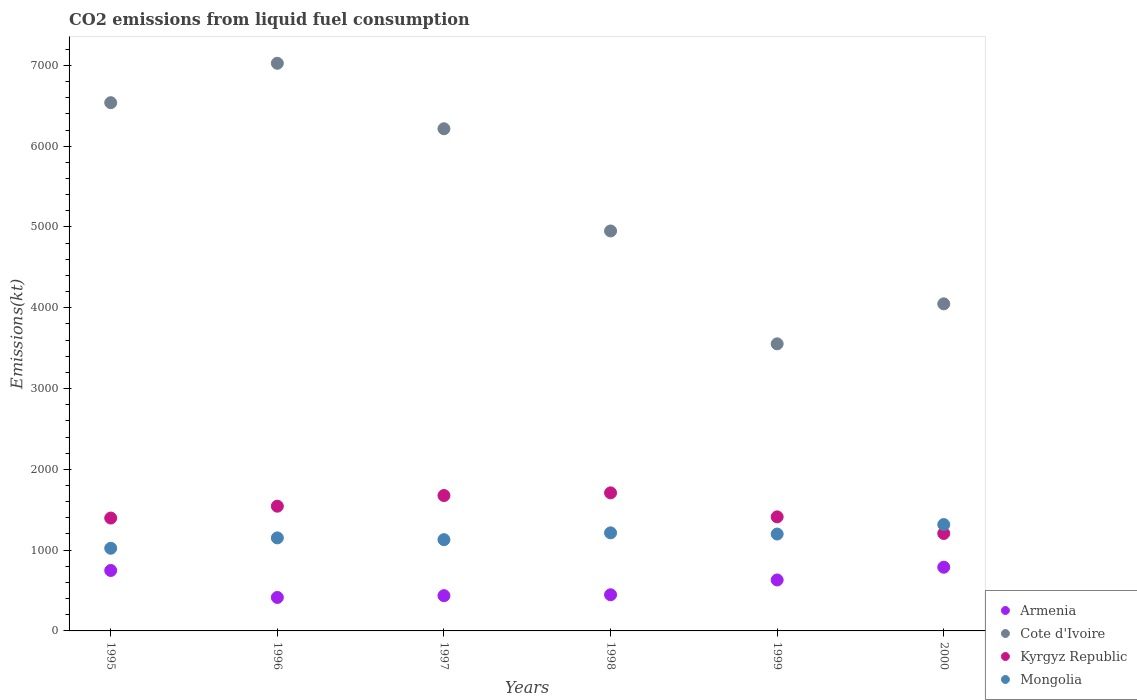What is the amount of CO2 emitted in Armenia in 2000?
Make the answer very short. 788.4. Across all years, what is the maximum amount of CO2 emitted in Armenia?
Keep it short and to the point. 788.4. Across all years, what is the minimum amount of CO2 emitted in Cote d'Ivoire?
Your answer should be compact. 3553.32. What is the total amount of CO2 emitted in Kyrgyz Republic in the graph?
Give a very brief answer. 8943.81. What is the difference between the amount of CO2 emitted in Kyrgyz Republic in 1997 and that in 1998?
Your response must be concise. -33. What is the difference between the amount of CO2 emitted in Mongolia in 1995 and the amount of CO2 emitted in Cote d'Ivoire in 1997?
Provide a succinct answer. -5192.47. What is the average amount of CO2 emitted in Kyrgyz Republic per year?
Provide a succinct answer. 1490.64. In the year 1996, what is the difference between the amount of CO2 emitted in Kyrgyz Republic and amount of CO2 emitted in Mongolia?
Provide a succinct answer. 392.37. What is the ratio of the amount of CO2 emitted in Cote d'Ivoire in 1996 to that in 1998?
Make the answer very short. 1.42. Is the amount of CO2 emitted in Cote d'Ivoire in 1996 less than that in 1997?
Give a very brief answer. No. What is the difference between the highest and the second highest amount of CO2 emitted in Cote d'Ivoire?
Your answer should be very brief. 487.71. What is the difference between the highest and the lowest amount of CO2 emitted in Kyrgyz Republic?
Offer a terse response. 502.38. Is the sum of the amount of CO2 emitted in Armenia in 1995 and 1999 greater than the maximum amount of CO2 emitted in Cote d'Ivoire across all years?
Make the answer very short. No. Is the amount of CO2 emitted in Kyrgyz Republic strictly greater than the amount of CO2 emitted in Mongolia over the years?
Give a very brief answer. No. Is the amount of CO2 emitted in Mongolia strictly less than the amount of CO2 emitted in Kyrgyz Republic over the years?
Keep it short and to the point. No. How many dotlines are there?
Keep it short and to the point. 4. What is the difference between two consecutive major ticks on the Y-axis?
Your answer should be compact. 1000. Are the values on the major ticks of Y-axis written in scientific E-notation?
Give a very brief answer. No. Does the graph contain any zero values?
Offer a very short reply. No. How are the legend labels stacked?
Give a very brief answer. Vertical. What is the title of the graph?
Offer a terse response. CO2 emissions from liquid fuel consumption. What is the label or title of the Y-axis?
Make the answer very short. Emissions(kt). What is the Emissions(kt) in Armenia in 1995?
Give a very brief answer. 748.07. What is the Emissions(kt) of Cote d'Ivoire in 1995?
Your answer should be compact. 6538.26. What is the Emissions(kt) in Kyrgyz Republic in 1995?
Keep it short and to the point. 1397.13. What is the Emissions(kt) of Mongolia in 1995?
Provide a short and direct response. 1023.09. What is the Emissions(kt) in Armenia in 1996?
Offer a terse response. 414.37. What is the Emissions(kt) of Cote d'Ivoire in 1996?
Offer a terse response. 7025.97. What is the Emissions(kt) of Kyrgyz Republic in 1996?
Your answer should be compact. 1543.81. What is the Emissions(kt) of Mongolia in 1996?
Provide a short and direct response. 1151.44. What is the Emissions(kt) of Armenia in 1997?
Your answer should be very brief. 436.37. What is the Emissions(kt) in Cote d'Ivoire in 1997?
Provide a short and direct response. 6215.56. What is the Emissions(kt) of Kyrgyz Republic in 1997?
Offer a very short reply. 1675.82. What is the Emissions(kt) in Mongolia in 1997?
Offer a terse response. 1129.44. What is the Emissions(kt) in Armenia in 1998?
Provide a short and direct response. 447.37. What is the Emissions(kt) in Cote d'Ivoire in 1998?
Give a very brief answer. 4950.45. What is the Emissions(kt) in Kyrgyz Republic in 1998?
Your response must be concise. 1708.82. What is the Emissions(kt) of Mongolia in 1998?
Make the answer very short. 1213.78. What is the Emissions(kt) in Armenia in 1999?
Your answer should be compact. 630.72. What is the Emissions(kt) in Cote d'Ivoire in 1999?
Keep it short and to the point. 3553.32. What is the Emissions(kt) in Kyrgyz Republic in 1999?
Make the answer very short. 1411.8. What is the Emissions(kt) of Mongolia in 1999?
Ensure brevity in your answer.  1199.11. What is the Emissions(kt) in Armenia in 2000?
Offer a very short reply. 788.4. What is the Emissions(kt) of Cote d'Ivoire in 2000?
Offer a very short reply. 4048.37. What is the Emissions(kt) in Kyrgyz Republic in 2000?
Make the answer very short. 1206.44. What is the Emissions(kt) of Mongolia in 2000?
Ensure brevity in your answer.  1316.45. Across all years, what is the maximum Emissions(kt) in Armenia?
Your answer should be very brief. 788.4. Across all years, what is the maximum Emissions(kt) in Cote d'Ivoire?
Give a very brief answer. 7025.97. Across all years, what is the maximum Emissions(kt) in Kyrgyz Republic?
Offer a very short reply. 1708.82. Across all years, what is the maximum Emissions(kt) of Mongolia?
Keep it short and to the point. 1316.45. Across all years, what is the minimum Emissions(kt) of Armenia?
Your answer should be compact. 414.37. Across all years, what is the minimum Emissions(kt) in Cote d'Ivoire?
Give a very brief answer. 3553.32. Across all years, what is the minimum Emissions(kt) of Kyrgyz Republic?
Make the answer very short. 1206.44. Across all years, what is the minimum Emissions(kt) of Mongolia?
Your answer should be compact. 1023.09. What is the total Emissions(kt) in Armenia in the graph?
Provide a short and direct response. 3465.32. What is the total Emissions(kt) in Cote d'Ivoire in the graph?
Offer a terse response. 3.23e+04. What is the total Emissions(kt) in Kyrgyz Republic in the graph?
Offer a very short reply. 8943.81. What is the total Emissions(kt) of Mongolia in the graph?
Offer a terse response. 7033.31. What is the difference between the Emissions(kt) in Armenia in 1995 and that in 1996?
Your answer should be compact. 333.7. What is the difference between the Emissions(kt) of Cote d'Ivoire in 1995 and that in 1996?
Your answer should be very brief. -487.71. What is the difference between the Emissions(kt) of Kyrgyz Republic in 1995 and that in 1996?
Provide a short and direct response. -146.68. What is the difference between the Emissions(kt) in Mongolia in 1995 and that in 1996?
Offer a very short reply. -128.34. What is the difference between the Emissions(kt) in Armenia in 1995 and that in 1997?
Give a very brief answer. 311.69. What is the difference between the Emissions(kt) in Cote d'Ivoire in 1995 and that in 1997?
Your answer should be very brief. 322.7. What is the difference between the Emissions(kt) of Kyrgyz Republic in 1995 and that in 1997?
Keep it short and to the point. -278.69. What is the difference between the Emissions(kt) in Mongolia in 1995 and that in 1997?
Ensure brevity in your answer.  -106.34. What is the difference between the Emissions(kt) of Armenia in 1995 and that in 1998?
Offer a very short reply. 300.69. What is the difference between the Emissions(kt) of Cote d'Ivoire in 1995 and that in 1998?
Keep it short and to the point. 1587.81. What is the difference between the Emissions(kt) in Kyrgyz Republic in 1995 and that in 1998?
Offer a very short reply. -311.69. What is the difference between the Emissions(kt) of Mongolia in 1995 and that in 1998?
Make the answer very short. -190.68. What is the difference between the Emissions(kt) in Armenia in 1995 and that in 1999?
Provide a short and direct response. 117.34. What is the difference between the Emissions(kt) of Cote d'Ivoire in 1995 and that in 1999?
Your answer should be compact. 2984.94. What is the difference between the Emissions(kt) of Kyrgyz Republic in 1995 and that in 1999?
Provide a succinct answer. -14.67. What is the difference between the Emissions(kt) of Mongolia in 1995 and that in 1999?
Give a very brief answer. -176.02. What is the difference between the Emissions(kt) in Armenia in 1995 and that in 2000?
Make the answer very short. -40.34. What is the difference between the Emissions(kt) in Cote d'Ivoire in 1995 and that in 2000?
Provide a short and direct response. 2489.89. What is the difference between the Emissions(kt) in Kyrgyz Republic in 1995 and that in 2000?
Your answer should be compact. 190.68. What is the difference between the Emissions(kt) in Mongolia in 1995 and that in 2000?
Your answer should be compact. -293.36. What is the difference between the Emissions(kt) in Armenia in 1996 and that in 1997?
Your answer should be very brief. -22. What is the difference between the Emissions(kt) of Cote d'Ivoire in 1996 and that in 1997?
Provide a succinct answer. 810.41. What is the difference between the Emissions(kt) in Kyrgyz Republic in 1996 and that in 1997?
Ensure brevity in your answer.  -132.01. What is the difference between the Emissions(kt) of Mongolia in 1996 and that in 1997?
Your response must be concise. 22. What is the difference between the Emissions(kt) of Armenia in 1996 and that in 1998?
Provide a short and direct response. -33. What is the difference between the Emissions(kt) of Cote d'Ivoire in 1996 and that in 1998?
Keep it short and to the point. 2075.52. What is the difference between the Emissions(kt) of Kyrgyz Republic in 1996 and that in 1998?
Provide a short and direct response. -165.01. What is the difference between the Emissions(kt) of Mongolia in 1996 and that in 1998?
Offer a very short reply. -62.34. What is the difference between the Emissions(kt) of Armenia in 1996 and that in 1999?
Your answer should be very brief. -216.35. What is the difference between the Emissions(kt) of Cote d'Ivoire in 1996 and that in 1999?
Your answer should be compact. 3472.65. What is the difference between the Emissions(kt) of Kyrgyz Republic in 1996 and that in 1999?
Your response must be concise. 132.01. What is the difference between the Emissions(kt) in Mongolia in 1996 and that in 1999?
Offer a very short reply. -47.67. What is the difference between the Emissions(kt) of Armenia in 1996 and that in 2000?
Your answer should be very brief. -374.03. What is the difference between the Emissions(kt) of Cote d'Ivoire in 1996 and that in 2000?
Provide a succinct answer. 2977.6. What is the difference between the Emissions(kt) in Kyrgyz Republic in 1996 and that in 2000?
Keep it short and to the point. 337.36. What is the difference between the Emissions(kt) in Mongolia in 1996 and that in 2000?
Offer a terse response. -165.01. What is the difference between the Emissions(kt) in Armenia in 1997 and that in 1998?
Your answer should be compact. -11. What is the difference between the Emissions(kt) of Cote d'Ivoire in 1997 and that in 1998?
Ensure brevity in your answer.  1265.12. What is the difference between the Emissions(kt) of Kyrgyz Republic in 1997 and that in 1998?
Your response must be concise. -33. What is the difference between the Emissions(kt) of Mongolia in 1997 and that in 1998?
Provide a succinct answer. -84.34. What is the difference between the Emissions(kt) in Armenia in 1997 and that in 1999?
Offer a terse response. -194.35. What is the difference between the Emissions(kt) of Cote d'Ivoire in 1997 and that in 1999?
Make the answer very short. 2662.24. What is the difference between the Emissions(kt) in Kyrgyz Republic in 1997 and that in 1999?
Offer a terse response. 264.02. What is the difference between the Emissions(kt) in Mongolia in 1997 and that in 1999?
Give a very brief answer. -69.67. What is the difference between the Emissions(kt) of Armenia in 1997 and that in 2000?
Ensure brevity in your answer.  -352.03. What is the difference between the Emissions(kt) of Cote d'Ivoire in 1997 and that in 2000?
Ensure brevity in your answer.  2167.2. What is the difference between the Emissions(kt) of Kyrgyz Republic in 1997 and that in 2000?
Your answer should be compact. 469.38. What is the difference between the Emissions(kt) in Mongolia in 1997 and that in 2000?
Make the answer very short. -187.02. What is the difference between the Emissions(kt) of Armenia in 1998 and that in 1999?
Keep it short and to the point. -183.35. What is the difference between the Emissions(kt) of Cote d'Ivoire in 1998 and that in 1999?
Your answer should be very brief. 1397.13. What is the difference between the Emissions(kt) in Kyrgyz Republic in 1998 and that in 1999?
Your answer should be very brief. 297.03. What is the difference between the Emissions(kt) of Mongolia in 1998 and that in 1999?
Provide a short and direct response. 14.67. What is the difference between the Emissions(kt) of Armenia in 1998 and that in 2000?
Provide a short and direct response. -341.03. What is the difference between the Emissions(kt) of Cote d'Ivoire in 1998 and that in 2000?
Make the answer very short. 902.08. What is the difference between the Emissions(kt) in Kyrgyz Republic in 1998 and that in 2000?
Offer a very short reply. 502.38. What is the difference between the Emissions(kt) in Mongolia in 1998 and that in 2000?
Provide a succinct answer. -102.68. What is the difference between the Emissions(kt) of Armenia in 1999 and that in 2000?
Your response must be concise. -157.68. What is the difference between the Emissions(kt) of Cote d'Ivoire in 1999 and that in 2000?
Provide a succinct answer. -495.05. What is the difference between the Emissions(kt) of Kyrgyz Republic in 1999 and that in 2000?
Your answer should be very brief. 205.35. What is the difference between the Emissions(kt) of Mongolia in 1999 and that in 2000?
Make the answer very short. -117.34. What is the difference between the Emissions(kt) of Armenia in 1995 and the Emissions(kt) of Cote d'Ivoire in 1996?
Offer a very short reply. -6277.9. What is the difference between the Emissions(kt) in Armenia in 1995 and the Emissions(kt) in Kyrgyz Republic in 1996?
Provide a short and direct response. -795.74. What is the difference between the Emissions(kt) of Armenia in 1995 and the Emissions(kt) of Mongolia in 1996?
Give a very brief answer. -403.37. What is the difference between the Emissions(kt) of Cote d'Ivoire in 1995 and the Emissions(kt) of Kyrgyz Republic in 1996?
Keep it short and to the point. 4994.45. What is the difference between the Emissions(kt) of Cote d'Ivoire in 1995 and the Emissions(kt) of Mongolia in 1996?
Offer a terse response. 5386.82. What is the difference between the Emissions(kt) of Kyrgyz Republic in 1995 and the Emissions(kt) of Mongolia in 1996?
Ensure brevity in your answer.  245.69. What is the difference between the Emissions(kt) of Armenia in 1995 and the Emissions(kt) of Cote d'Ivoire in 1997?
Ensure brevity in your answer.  -5467.5. What is the difference between the Emissions(kt) of Armenia in 1995 and the Emissions(kt) of Kyrgyz Republic in 1997?
Provide a short and direct response. -927.75. What is the difference between the Emissions(kt) of Armenia in 1995 and the Emissions(kt) of Mongolia in 1997?
Your response must be concise. -381.37. What is the difference between the Emissions(kt) in Cote d'Ivoire in 1995 and the Emissions(kt) in Kyrgyz Republic in 1997?
Your answer should be compact. 4862.44. What is the difference between the Emissions(kt) of Cote d'Ivoire in 1995 and the Emissions(kt) of Mongolia in 1997?
Your answer should be compact. 5408.82. What is the difference between the Emissions(kt) of Kyrgyz Republic in 1995 and the Emissions(kt) of Mongolia in 1997?
Your answer should be compact. 267.69. What is the difference between the Emissions(kt) of Armenia in 1995 and the Emissions(kt) of Cote d'Ivoire in 1998?
Your answer should be compact. -4202.38. What is the difference between the Emissions(kt) of Armenia in 1995 and the Emissions(kt) of Kyrgyz Republic in 1998?
Ensure brevity in your answer.  -960.75. What is the difference between the Emissions(kt) of Armenia in 1995 and the Emissions(kt) of Mongolia in 1998?
Ensure brevity in your answer.  -465.71. What is the difference between the Emissions(kt) in Cote d'Ivoire in 1995 and the Emissions(kt) in Kyrgyz Republic in 1998?
Provide a short and direct response. 4829.44. What is the difference between the Emissions(kt) of Cote d'Ivoire in 1995 and the Emissions(kt) of Mongolia in 1998?
Give a very brief answer. 5324.48. What is the difference between the Emissions(kt) in Kyrgyz Republic in 1995 and the Emissions(kt) in Mongolia in 1998?
Offer a very short reply. 183.35. What is the difference between the Emissions(kt) of Armenia in 1995 and the Emissions(kt) of Cote d'Ivoire in 1999?
Ensure brevity in your answer.  -2805.26. What is the difference between the Emissions(kt) of Armenia in 1995 and the Emissions(kt) of Kyrgyz Republic in 1999?
Make the answer very short. -663.73. What is the difference between the Emissions(kt) in Armenia in 1995 and the Emissions(kt) in Mongolia in 1999?
Give a very brief answer. -451.04. What is the difference between the Emissions(kt) in Cote d'Ivoire in 1995 and the Emissions(kt) in Kyrgyz Republic in 1999?
Your answer should be compact. 5126.47. What is the difference between the Emissions(kt) of Cote d'Ivoire in 1995 and the Emissions(kt) of Mongolia in 1999?
Offer a very short reply. 5339.15. What is the difference between the Emissions(kt) in Kyrgyz Republic in 1995 and the Emissions(kt) in Mongolia in 1999?
Provide a succinct answer. 198.02. What is the difference between the Emissions(kt) of Armenia in 1995 and the Emissions(kt) of Cote d'Ivoire in 2000?
Offer a terse response. -3300.3. What is the difference between the Emissions(kt) in Armenia in 1995 and the Emissions(kt) in Kyrgyz Republic in 2000?
Ensure brevity in your answer.  -458.38. What is the difference between the Emissions(kt) of Armenia in 1995 and the Emissions(kt) of Mongolia in 2000?
Offer a very short reply. -568.38. What is the difference between the Emissions(kt) of Cote d'Ivoire in 1995 and the Emissions(kt) of Kyrgyz Republic in 2000?
Provide a succinct answer. 5331.82. What is the difference between the Emissions(kt) in Cote d'Ivoire in 1995 and the Emissions(kt) in Mongolia in 2000?
Offer a terse response. 5221.81. What is the difference between the Emissions(kt) of Kyrgyz Republic in 1995 and the Emissions(kt) of Mongolia in 2000?
Provide a succinct answer. 80.67. What is the difference between the Emissions(kt) in Armenia in 1996 and the Emissions(kt) in Cote d'Ivoire in 1997?
Your response must be concise. -5801.19. What is the difference between the Emissions(kt) of Armenia in 1996 and the Emissions(kt) of Kyrgyz Republic in 1997?
Your response must be concise. -1261.45. What is the difference between the Emissions(kt) of Armenia in 1996 and the Emissions(kt) of Mongolia in 1997?
Give a very brief answer. -715.07. What is the difference between the Emissions(kt) of Cote d'Ivoire in 1996 and the Emissions(kt) of Kyrgyz Republic in 1997?
Make the answer very short. 5350.15. What is the difference between the Emissions(kt) in Cote d'Ivoire in 1996 and the Emissions(kt) in Mongolia in 1997?
Offer a terse response. 5896.54. What is the difference between the Emissions(kt) in Kyrgyz Republic in 1996 and the Emissions(kt) in Mongolia in 1997?
Provide a succinct answer. 414.37. What is the difference between the Emissions(kt) of Armenia in 1996 and the Emissions(kt) of Cote d'Ivoire in 1998?
Provide a short and direct response. -4536.08. What is the difference between the Emissions(kt) in Armenia in 1996 and the Emissions(kt) in Kyrgyz Republic in 1998?
Give a very brief answer. -1294.45. What is the difference between the Emissions(kt) in Armenia in 1996 and the Emissions(kt) in Mongolia in 1998?
Make the answer very short. -799.41. What is the difference between the Emissions(kt) in Cote d'Ivoire in 1996 and the Emissions(kt) in Kyrgyz Republic in 1998?
Ensure brevity in your answer.  5317.15. What is the difference between the Emissions(kt) of Cote d'Ivoire in 1996 and the Emissions(kt) of Mongolia in 1998?
Ensure brevity in your answer.  5812.19. What is the difference between the Emissions(kt) of Kyrgyz Republic in 1996 and the Emissions(kt) of Mongolia in 1998?
Provide a short and direct response. 330.03. What is the difference between the Emissions(kt) of Armenia in 1996 and the Emissions(kt) of Cote d'Ivoire in 1999?
Give a very brief answer. -3138.95. What is the difference between the Emissions(kt) of Armenia in 1996 and the Emissions(kt) of Kyrgyz Republic in 1999?
Offer a very short reply. -997.42. What is the difference between the Emissions(kt) in Armenia in 1996 and the Emissions(kt) in Mongolia in 1999?
Offer a very short reply. -784.74. What is the difference between the Emissions(kt) in Cote d'Ivoire in 1996 and the Emissions(kt) in Kyrgyz Republic in 1999?
Your answer should be very brief. 5614.18. What is the difference between the Emissions(kt) of Cote d'Ivoire in 1996 and the Emissions(kt) of Mongolia in 1999?
Your answer should be compact. 5826.86. What is the difference between the Emissions(kt) in Kyrgyz Republic in 1996 and the Emissions(kt) in Mongolia in 1999?
Offer a terse response. 344.7. What is the difference between the Emissions(kt) of Armenia in 1996 and the Emissions(kt) of Cote d'Ivoire in 2000?
Your answer should be very brief. -3634. What is the difference between the Emissions(kt) in Armenia in 1996 and the Emissions(kt) in Kyrgyz Republic in 2000?
Offer a very short reply. -792.07. What is the difference between the Emissions(kt) in Armenia in 1996 and the Emissions(kt) in Mongolia in 2000?
Your answer should be compact. -902.08. What is the difference between the Emissions(kt) in Cote d'Ivoire in 1996 and the Emissions(kt) in Kyrgyz Republic in 2000?
Provide a succinct answer. 5819.53. What is the difference between the Emissions(kt) in Cote d'Ivoire in 1996 and the Emissions(kt) in Mongolia in 2000?
Your answer should be very brief. 5709.52. What is the difference between the Emissions(kt) in Kyrgyz Republic in 1996 and the Emissions(kt) in Mongolia in 2000?
Your answer should be very brief. 227.35. What is the difference between the Emissions(kt) in Armenia in 1997 and the Emissions(kt) in Cote d'Ivoire in 1998?
Your answer should be very brief. -4514.08. What is the difference between the Emissions(kt) of Armenia in 1997 and the Emissions(kt) of Kyrgyz Republic in 1998?
Your answer should be very brief. -1272.45. What is the difference between the Emissions(kt) in Armenia in 1997 and the Emissions(kt) in Mongolia in 1998?
Your answer should be compact. -777.4. What is the difference between the Emissions(kt) in Cote d'Ivoire in 1997 and the Emissions(kt) in Kyrgyz Republic in 1998?
Make the answer very short. 4506.74. What is the difference between the Emissions(kt) of Cote d'Ivoire in 1997 and the Emissions(kt) of Mongolia in 1998?
Provide a short and direct response. 5001.79. What is the difference between the Emissions(kt) in Kyrgyz Republic in 1997 and the Emissions(kt) in Mongolia in 1998?
Your answer should be compact. 462.04. What is the difference between the Emissions(kt) in Armenia in 1997 and the Emissions(kt) in Cote d'Ivoire in 1999?
Provide a succinct answer. -3116.95. What is the difference between the Emissions(kt) in Armenia in 1997 and the Emissions(kt) in Kyrgyz Republic in 1999?
Offer a terse response. -975.42. What is the difference between the Emissions(kt) of Armenia in 1997 and the Emissions(kt) of Mongolia in 1999?
Give a very brief answer. -762.74. What is the difference between the Emissions(kt) in Cote d'Ivoire in 1997 and the Emissions(kt) in Kyrgyz Republic in 1999?
Provide a succinct answer. 4803.77. What is the difference between the Emissions(kt) of Cote d'Ivoire in 1997 and the Emissions(kt) of Mongolia in 1999?
Your answer should be compact. 5016.46. What is the difference between the Emissions(kt) in Kyrgyz Republic in 1997 and the Emissions(kt) in Mongolia in 1999?
Offer a very short reply. 476.71. What is the difference between the Emissions(kt) of Armenia in 1997 and the Emissions(kt) of Cote d'Ivoire in 2000?
Provide a short and direct response. -3611.99. What is the difference between the Emissions(kt) of Armenia in 1997 and the Emissions(kt) of Kyrgyz Republic in 2000?
Give a very brief answer. -770.07. What is the difference between the Emissions(kt) of Armenia in 1997 and the Emissions(kt) of Mongolia in 2000?
Keep it short and to the point. -880.08. What is the difference between the Emissions(kt) of Cote d'Ivoire in 1997 and the Emissions(kt) of Kyrgyz Republic in 2000?
Ensure brevity in your answer.  5009.12. What is the difference between the Emissions(kt) of Cote d'Ivoire in 1997 and the Emissions(kt) of Mongolia in 2000?
Keep it short and to the point. 4899.11. What is the difference between the Emissions(kt) of Kyrgyz Republic in 1997 and the Emissions(kt) of Mongolia in 2000?
Make the answer very short. 359.37. What is the difference between the Emissions(kt) of Armenia in 1998 and the Emissions(kt) of Cote d'Ivoire in 1999?
Provide a succinct answer. -3105.95. What is the difference between the Emissions(kt) in Armenia in 1998 and the Emissions(kt) in Kyrgyz Republic in 1999?
Provide a succinct answer. -964.42. What is the difference between the Emissions(kt) in Armenia in 1998 and the Emissions(kt) in Mongolia in 1999?
Keep it short and to the point. -751.74. What is the difference between the Emissions(kt) of Cote d'Ivoire in 1998 and the Emissions(kt) of Kyrgyz Republic in 1999?
Provide a succinct answer. 3538.66. What is the difference between the Emissions(kt) of Cote d'Ivoire in 1998 and the Emissions(kt) of Mongolia in 1999?
Offer a very short reply. 3751.34. What is the difference between the Emissions(kt) of Kyrgyz Republic in 1998 and the Emissions(kt) of Mongolia in 1999?
Your response must be concise. 509.71. What is the difference between the Emissions(kt) of Armenia in 1998 and the Emissions(kt) of Cote d'Ivoire in 2000?
Give a very brief answer. -3600.99. What is the difference between the Emissions(kt) in Armenia in 1998 and the Emissions(kt) in Kyrgyz Republic in 2000?
Your response must be concise. -759.07. What is the difference between the Emissions(kt) of Armenia in 1998 and the Emissions(kt) of Mongolia in 2000?
Keep it short and to the point. -869.08. What is the difference between the Emissions(kt) in Cote d'Ivoire in 1998 and the Emissions(kt) in Kyrgyz Republic in 2000?
Provide a short and direct response. 3744.01. What is the difference between the Emissions(kt) of Cote d'Ivoire in 1998 and the Emissions(kt) of Mongolia in 2000?
Give a very brief answer. 3634. What is the difference between the Emissions(kt) of Kyrgyz Republic in 1998 and the Emissions(kt) of Mongolia in 2000?
Provide a short and direct response. 392.37. What is the difference between the Emissions(kt) of Armenia in 1999 and the Emissions(kt) of Cote d'Ivoire in 2000?
Provide a succinct answer. -3417.64. What is the difference between the Emissions(kt) of Armenia in 1999 and the Emissions(kt) of Kyrgyz Republic in 2000?
Make the answer very short. -575.72. What is the difference between the Emissions(kt) in Armenia in 1999 and the Emissions(kt) in Mongolia in 2000?
Keep it short and to the point. -685.73. What is the difference between the Emissions(kt) of Cote d'Ivoire in 1999 and the Emissions(kt) of Kyrgyz Republic in 2000?
Ensure brevity in your answer.  2346.88. What is the difference between the Emissions(kt) in Cote d'Ivoire in 1999 and the Emissions(kt) in Mongolia in 2000?
Your answer should be compact. 2236.87. What is the difference between the Emissions(kt) of Kyrgyz Republic in 1999 and the Emissions(kt) of Mongolia in 2000?
Your response must be concise. 95.34. What is the average Emissions(kt) in Armenia per year?
Ensure brevity in your answer.  577.55. What is the average Emissions(kt) in Cote d'Ivoire per year?
Your response must be concise. 5388.66. What is the average Emissions(kt) of Kyrgyz Republic per year?
Provide a succinct answer. 1490.64. What is the average Emissions(kt) of Mongolia per year?
Keep it short and to the point. 1172.22. In the year 1995, what is the difference between the Emissions(kt) of Armenia and Emissions(kt) of Cote d'Ivoire?
Offer a very short reply. -5790.19. In the year 1995, what is the difference between the Emissions(kt) of Armenia and Emissions(kt) of Kyrgyz Republic?
Make the answer very short. -649.06. In the year 1995, what is the difference between the Emissions(kt) in Armenia and Emissions(kt) in Mongolia?
Keep it short and to the point. -275.02. In the year 1995, what is the difference between the Emissions(kt) in Cote d'Ivoire and Emissions(kt) in Kyrgyz Republic?
Provide a succinct answer. 5141.13. In the year 1995, what is the difference between the Emissions(kt) in Cote d'Ivoire and Emissions(kt) in Mongolia?
Your answer should be compact. 5515.17. In the year 1995, what is the difference between the Emissions(kt) of Kyrgyz Republic and Emissions(kt) of Mongolia?
Provide a succinct answer. 374.03. In the year 1996, what is the difference between the Emissions(kt) in Armenia and Emissions(kt) in Cote d'Ivoire?
Give a very brief answer. -6611.6. In the year 1996, what is the difference between the Emissions(kt) of Armenia and Emissions(kt) of Kyrgyz Republic?
Your answer should be compact. -1129.44. In the year 1996, what is the difference between the Emissions(kt) of Armenia and Emissions(kt) of Mongolia?
Make the answer very short. -737.07. In the year 1996, what is the difference between the Emissions(kt) in Cote d'Ivoire and Emissions(kt) in Kyrgyz Republic?
Provide a succinct answer. 5482.16. In the year 1996, what is the difference between the Emissions(kt) of Cote d'Ivoire and Emissions(kt) of Mongolia?
Make the answer very short. 5874.53. In the year 1996, what is the difference between the Emissions(kt) in Kyrgyz Republic and Emissions(kt) in Mongolia?
Give a very brief answer. 392.37. In the year 1997, what is the difference between the Emissions(kt) in Armenia and Emissions(kt) in Cote d'Ivoire?
Ensure brevity in your answer.  -5779.19. In the year 1997, what is the difference between the Emissions(kt) of Armenia and Emissions(kt) of Kyrgyz Republic?
Your answer should be very brief. -1239.45. In the year 1997, what is the difference between the Emissions(kt) in Armenia and Emissions(kt) in Mongolia?
Give a very brief answer. -693.06. In the year 1997, what is the difference between the Emissions(kt) of Cote d'Ivoire and Emissions(kt) of Kyrgyz Republic?
Provide a short and direct response. 4539.75. In the year 1997, what is the difference between the Emissions(kt) of Cote d'Ivoire and Emissions(kt) of Mongolia?
Provide a succinct answer. 5086.13. In the year 1997, what is the difference between the Emissions(kt) in Kyrgyz Republic and Emissions(kt) in Mongolia?
Keep it short and to the point. 546.38. In the year 1998, what is the difference between the Emissions(kt) of Armenia and Emissions(kt) of Cote d'Ivoire?
Provide a short and direct response. -4503.08. In the year 1998, what is the difference between the Emissions(kt) of Armenia and Emissions(kt) of Kyrgyz Republic?
Offer a very short reply. -1261.45. In the year 1998, what is the difference between the Emissions(kt) in Armenia and Emissions(kt) in Mongolia?
Offer a terse response. -766.4. In the year 1998, what is the difference between the Emissions(kt) in Cote d'Ivoire and Emissions(kt) in Kyrgyz Republic?
Provide a succinct answer. 3241.63. In the year 1998, what is the difference between the Emissions(kt) in Cote d'Ivoire and Emissions(kt) in Mongolia?
Your answer should be compact. 3736.67. In the year 1998, what is the difference between the Emissions(kt) in Kyrgyz Republic and Emissions(kt) in Mongolia?
Your answer should be very brief. 495.05. In the year 1999, what is the difference between the Emissions(kt) of Armenia and Emissions(kt) of Cote d'Ivoire?
Your response must be concise. -2922.6. In the year 1999, what is the difference between the Emissions(kt) in Armenia and Emissions(kt) in Kyrgyz Republic?
Make the answer very short. -781.07. In the year 1999, what is the difference between the Emissions(kt) in Armenia and Emissions(kt) in Mongolia?
Ensure brevity in your answer.  -568.38. In the year 1999, what is the difference between the Emissions(kt) of Cote d'Ivoire and Emissions(kt) of Kyrgyz Republic?
Offer a very short reply. 2141.53. In the year 1999, what is the difference between the Emissions(kt) in Cote d'Ivoire and Emissions(kt) in Mongolia?
Provide a succinct answer. 2354.21. In the year 1999, what is the difference between the Emissions(kt) in Kyrgyz Republic and Emissions(kt) in Mongolia?
Your answer should be very brief. 212.69. In the year 2000, what is the difference between the Emissions(kt) of Armenia and Emissions(kt) of Cote d'Ivoire?
Give a very brief answer. -3259.96. In the year 2000, what is the difference between the Emissions(kt) of Armenia and Emissions(kt) of Kyrgyz Republic?
Ensure brevity in your answer.  -418.04. In the year 2000, what is the difference between the Emissions(kt) of Armenia and Emissions(kt) of Mongolia?
Ensure brevity in your answer.  -528.05. In the year 2000, what is the difference between the Emissions(kt) of Cote d'Ivoire and Emissions(kt) of Kyrgyz Republic?
Provide a succinct answer. 2841.93. In the year 2000, what is the difference between the Emissions(kt) of Cote d'Ivoire and Emissions(kt) of Mongolia?
Your response must be concise. 2731.91. In the year 2000, what is the difference between the Emissions(kt) of Kyrgyz Republic and Emissions(kt) of Mongolia?
Give a very brief answer. -110.01. What is the ratio of the Emissions(kt) in Armenia in 1995 to that in 1996?
Make the answer very short. 1.81. What is the ratio of the Emissions(kt) in Cote d'Ivoire in 1995 to that in 1996?
Keep it short and to the point. 0.93. What is the ratio of the Emissions(kt) in Kyrgyz Republic in 1995 to that in 1996?
Provide a short and direct response. 0.91. What is the ratio of the Emissions(kt) of Mongolia in 1995 to that in 1996?
Offer a terse response. 0.89. What is the ratio of the Emissions(kt) in Armenia in 1995 to that in 1997?
Offer a terse response. 1.71. What is the ratio of the Emissions(kt) in Cote d'Ivoire in 1995 to that in 1997?
Give a very brief answer. 1.05. What is the ratio of the Emissions(kt) in Kyrgyz Republic in 1995 to that in 1997?
Your answer should be very brief. 0.83. What is the ratio of the Emissions(kt) in Mongolia in 1995 to that in 1997?
Your answer should be very brief. 0.91. What is the ratio of the Emissions(kt) in Armenia in 1995 to that in 1998?
Make the answer very short. 1.67. What is the ratio of the Emissions(kt) in Cote d'Ivoire in 1995 to that in 1998?
Ensure brevity in your answer.  1.32. What is the ratio of the Emissions(kt) in Kyrgyz Republic in 1995 to that in 1998?
Your answer should be compact. 0.82. What is the ratio of the Emissions(kt) of Mongolia in 1995 to that in 1998?
Offer a very short reply. 0.84. What is the ratio of the Emissions(kt) in Armenia in 1995 to that in 1999?
Your answer should be compact. 1.19. What is the ratio of the Emissions(kt) in Cote d'Ivoire in 1995 to that in 1999?
Your answer should be very brief. 1.84. What is the ratio of the Emissions(kt) of Mongolia in 1995 to that in 1999?
Provide a short and direct response. 0.85. What is the ratio of the Emissions(kt) of Armenia in 1995 to that in 2000?
Provide a short and direct response. 0.95. What is the ratio of the Emissions(kt) in Cote d'Ivoire in 1995 to that in 2000?
Offer a terse response. 1.61. What is the ratio of the Emissions(kt) in Kyrgyz Republic in 1995 to that in 2000?
Your answer should be compact. 1.16. What is the ratio of the Emissions(kt) in Mongolia in 1995 to that in 2000?
Ensure brevity in your answer.  0.78. What is the ratio of the Emissions(kt) in Armenia in 1996 to that in 1997?
Give a very brief answer. 0.95. What is the ratio of the Emissions(kt) in Cote d'Ivoire in 1996 to that in 1997?
Keep it short and to the point. 1.13. What is the ratio of the Emissions(kt) of Kyrgyz Republic in 1996 to that in 1997?
Make the answer very short. 0.92. What is the ratio of the Emissions(kt) of Mongolia in 1996 to that in 1997?
Your answer should be compact. 1.02. What is the ratio of the Emissions(kt) in Armenia in 1996 to that in 1998?
Your answer should be very brief. 0.93. What is the ratio of the Emissions(kt) in Cote d'Ivoire in 1996 to that in 1998?
Offer a terse response. 1.42. What is the ratio of the Emissions(kt) in Kyrgyz Republic in 1996 to that in 1998?
Ensure brevity in your answer.  0.9. What is the ratio of the Emissions(kt) of Mongolia in 1996 to that in 1998?
Provide a short and direct response. 0.95. What is the ratio of the Emissions(kt) of Armenia in 1996 to that in 1999?
Ensure brevity in your answer.  0.66. What is the ratio of the Emissions(kt) of Cote d'Ivoire in 1996 to that in 1999?
Your response must be concise. 1.98. What is the ratio of the Emissions(kt) of Kyrgyz Republic in 1996 to that in 1999?
Provide a short and direct response. 1.09. What is the ratio of the Emissions(kt) of Mongolia in 1996 to that in 1999?
Keep it short and to the point. 0.96. What is the ratio of the Emissions(kt) of Armenia in 1996 to that in 2000?
Your answer should be very brief. 0.53. What is the ratio of the Emissions(kt) in Cote d'Ivoire in 1996 to that in 2000?
Make the answer very short. 1.74. What is the ratio of the Emissions(kt) in Kyrgyz Republic in 1996 to that in 2000?
Offer a terse response. 1.28. What is the ratio of the Emissions(kt) in Mongolia in 1996 to that in 2000?
Make the answer very short. 0.87. What is the ratio of the Emissions(kt) in Armenia in 1997 to that in 1998?
Provide a succinct answer. 0.98. What is the ratio of the Emissions(kt) in Cote d'Ivoire in 1997 to that in 1998?
Give a very brief answer. 1.26. What is the ratio of the Emissions(kt) in Kyrgyz Republic in 1997 to that in 1998?
Your answer should be very brief. 0.98. What is the ratio of the Emissions(kt) in Mongolia in 1997 to that in 1998?
Make the answer very short. 0.93. What is the ratio of the Emissions(kt) of Armenia in 1997 to that in 1999?
Give a very brief answer. 0.69. What is the ratio of the Emissions(kt) of Cote d'Ivoire in 1997 to that in 1999?
Give a very brief answer. 1.75. What is the ratio of the Emissions(kt) in Kyrgyz Republic in 1997 to that in 1999?
Offer a terse response. 1.19. What is the ratio of the Emissions(kt) in Mongolia in 1997 to that in 1999?
Offer a very short reply. 0.94. What is the ratio of the Emissions(kt) of Armenia in 1997 to that in 2000?
Make the answer very short. 0.55. What is the ratio of the Emissions(kt) of Cote d'Ivoire in 1997 to that in 2000?
Ensure brevity in your answer.  1.54. What is the ratio of the Emissions(kt) of Kyrgyz Republic in 1997 to that in 2000?
Your answer should be compact. 1.39. What is the ratio of the Emissions(kt) of Mongolia in 1997 to that in 2000?
Make the answer very short. 0.86. What is the ratio of the Emissions(kt) of Armenia in 1998 to that in 1999?
Your response must be concise. 0.71. What is the ratio of the Emissions(kt) in Cote d'Ivoire in 1998 to that in 1999?
Offer a very short reply. 1.39. What is the ratio of the Emissions(kt) in Kyrgyz Republic in 1998 to that in 1999?
Offer a very short reply. 1.21. What is the ratio of the Emissions(kt) in Mongolia in 1998 to that in 1999?
Your response must be concise. 1.01. What is the ratio of the Emissions(kt) of Armenia in 1998 to that in 2000?
Ensure brevity in your answer.  0.57. What is the ratio of the Emissions(kt) in Cote d'Ivoire in 1998 to that in 2000?
Make the answer very short. 1.22. What is the ratio of the Emissions(kt) in Kyrgyz Republic in 1998 to that in 2000?
Provide a succinct answer. 1.42. What is the ratio of the Emissions(kt) in Mongolia in 1998 to that in 2000?
Provide a short and direct response. 0.92. What is the ratio of the Emissions(kt) of Armenia in 1999 to that in 2000?
Provide a short and direct response. 0.8. What is the ratio of the Emissions(kt) of Cote d'Ivoire in 1999 to that in 2000?
Make the answer very short. 0.88. What is the ratio of the Emissions(kt) of Kyrgyz Republic in 1999 to that in 2000?
Keep it short and to the point. 1.17. What is the ratio of the Emissions(kt) in Mongolia in 1999 to that in 2000?
Provide a succinct answer. 0.91. What is the difference between the highest and the second highest Emissions(kt) in Armenia?
Give a very brief answer. 40.34. What is the difference between the highest and the second highest Emissions(kt) of Cote d'Ivoire?
Ensure brevity in your answer.  487.71. What is the difference between the highest and the second highest Emissions(kt) of Kyrgyz Republic?
Give a very brief answer. 33. What is the difference between the highest and the second highest Emissions(kt) in Mongolia?
Your response must be concise. 102.68. What is the difference between the highest and the lowest Emissions(kt) in Armenia?
Your answer should be very brief. 374.03. What is the difference between the highest and the lowest Emissions(kt) in Cote d'Ivoire?
Keep it short and to the point. 3472.65. What is the difference between the highest and the lowest Emissions(kt) in Kyrgyz Republic?
Give a very brief answer. 502.38. What is the difference between the highest and the lowest Emissions(kt) of Mongolia?
Offer a very short reply. 293.36. 